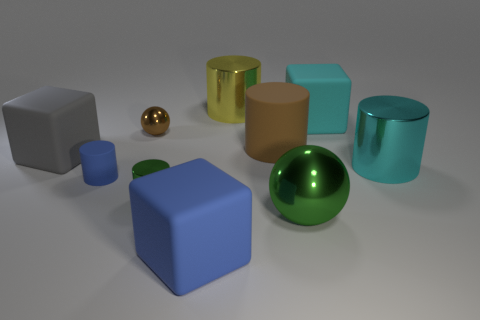There is a metal cylinder that is to the right of the big blue matte block and in front of the big yellow metallic object; what is its color?
Ensure brevity in your answer.  Cyan. Is there a large rubber cylinder that has the same color as the tiny matte cylinder?
Make the answer very short. No. Does the tiny cylinder left of the small ball have the same material as the large cyan thing behind the gray matte thing?
Offer a very short reply. Yes. What is the size of the blue rubber thing that is left of the large blue matte object?
Keep it short and to the point. Small. How big is the blue rubber cube?
Your response must be concise. Large. There is a rubber cube that is in front of the small cylinder to the left of the tiny shiny thing that is behind the tiny blue rubber cylinder; how big is it?
Offer a terse response. Large. Is there a tiny brown thing that has the same material as the big blue block?
Offer a terse response. No. What is the shape of the big brown object?
Your answer should be compact. Cylinder. What color is the tiny cylinder that is the same material as the big green sphere?
Provide a succinct answer. Green. What number of green things are either big metallic objects or large metallic cylinders?
Provide a short and direct response. 1. 